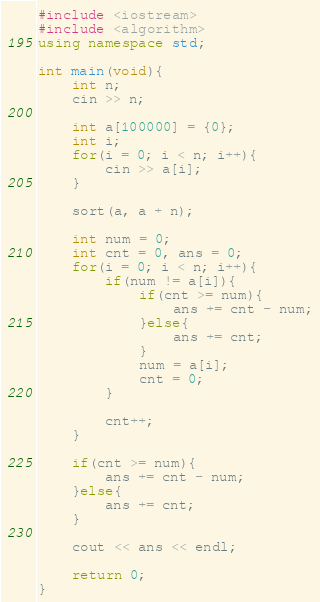<code> <loc_0><loc_0><loc_500><loc_500><_C++_>#include <iostream>
#include <algorithm>
using namespace std;

int main(void){
    int n;
    cin >> n;
    
    int a[100000] = {0};
    int i;
    for(i = 0; i < n; i++){
        cin >> a[i];
    }
    
    sort(a, a + n);
    
    int num = 0;
    int cnt = 0, ans = 0;
    for(i = 0; i < n; i++){
        if(num != a[i]){
            if(cnt >= num){
                ans += cnt - num;
            }else{
                ans += cnt;
            }
            num = a[i];
            cnt = 0;
        }
        
        cnt++;
    }
    
    if(cnt >= num){
        ans += cnt - num;
    }else{
        ans += cnt;
    }
    
    cout << ans << endl;
    
    return 0;
}
</code> 